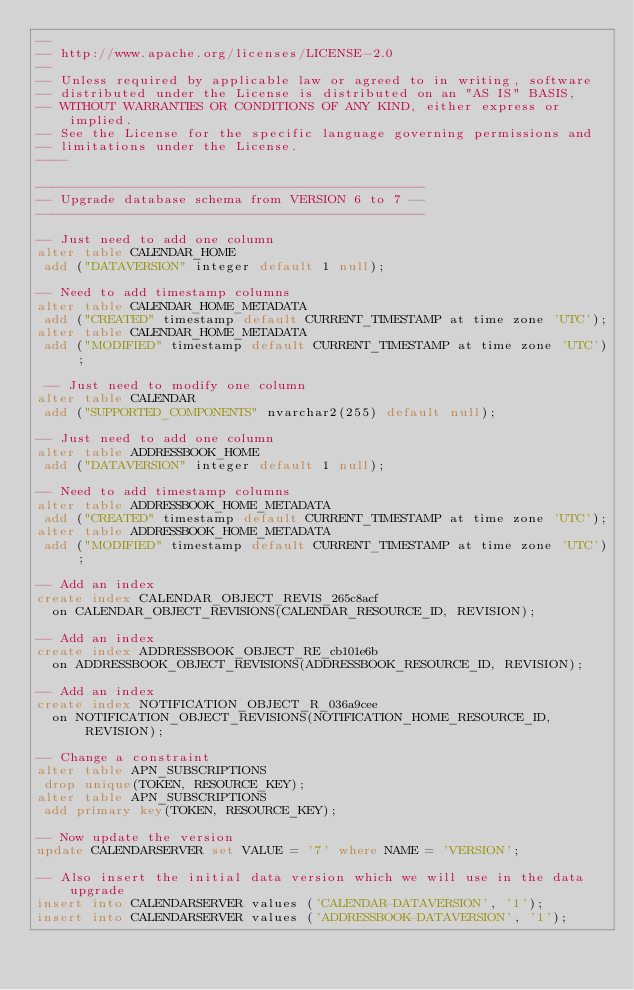<code> <loc_0><loc_0><loc_500><loc_500><_SQL_>--
-- http://www.apache.org/licenses/LICENSE-2.0
--
-- Unless required by applicable law or agreed to in writing, software
-- distributed under the License is distributed on an "AS IS" BASIS,
-- WITHOUT WARRANTIES OR CONDITIONS OF ANY KIND, either express or implied.
-- See the License for the specific language governing permissions and
-- limitations under the License.
----

-------------------------------------------------
-- Upgrade database schema from VERSION 6 to 7 --
-------------------------------------------------

-- Just need to add one column
alter table CALENDAR_HOME
 add ("DATAVERSION" integer default 1 null);
 
-- Need to add timestamp columns
alter table CALENDAR_HOME_METADATA
 add ("CREATED" timestamp default CURRENT_TIMESTAMP at time zone 'UTC');
alter table CALENDAR_HOME_METADATA
 add ("MODIFIED" timestamp default CURRENT_TIMESTAMP at time zone 'UTC');

 -- Just need to modify one column
alter table CALENDAR
 add ("SUPPORTED_COMPONENTS" nvarchar2(255) default null);

-- Just need to add one column
alter table ADDRESSBOOK_HOME
 add ("DATAVERSION" integer default 1 null);
 
-- Need to add timestamp columns
alter table ADDRESSBOOK_HOME_METADATA
 add ("CREATED" timestamp default CURRENT_TIMESTAMP at time zone 'UTC');
alter table ADDRESSBOOK_HOME_METADATA
 add ("MODIFIED" timestamp default CURRENT_TIMESTAMP at time zone 'UTC');

-- Add an index
create index CALENDAR_OBJECT_REVIS_265c8acf
  on CALENDAR_OBJECT_REVISIONS(CALENDAR_RESOURCE_ID, REVISION);

-- Add an index
create index ADDRESSBOOK_OBJECT_RE_cb101e6b
  on ADDRESSBOOK_OBJECT_REVISIONS(ADDRESSBOOK_RESOURCE_ID, REVISION);

-- Add an index
create index NOTIFICATION_OBJECT_R_036a9cee
  on NOTIFICATION_OBJECT_REVISIONS(NOTIFICATION_HOME_RESOURCE_ID, REVISION);

-- Change a constraint
alter table APN_SUBSCRIPTIONS
 drop unique(TOKEN, RESOURCE_KEY);
alter table APN_SUBSCRIPTIONS
 add primary key(TOKEN, RESOURCE_KEY);

-- Now update the version
update CALENDARSERVER set VALUE = '7' where NAME = 'VERSION';

-- Also insert the initial data version which we will use in the data upgrade
insert into CALENDARSERVER values ('CALENDAR-DATAVERSION', '1');
insert into CALENDARSERVER values ('ADDRESSBOOK-DATAVERSION', '1');
</code> 